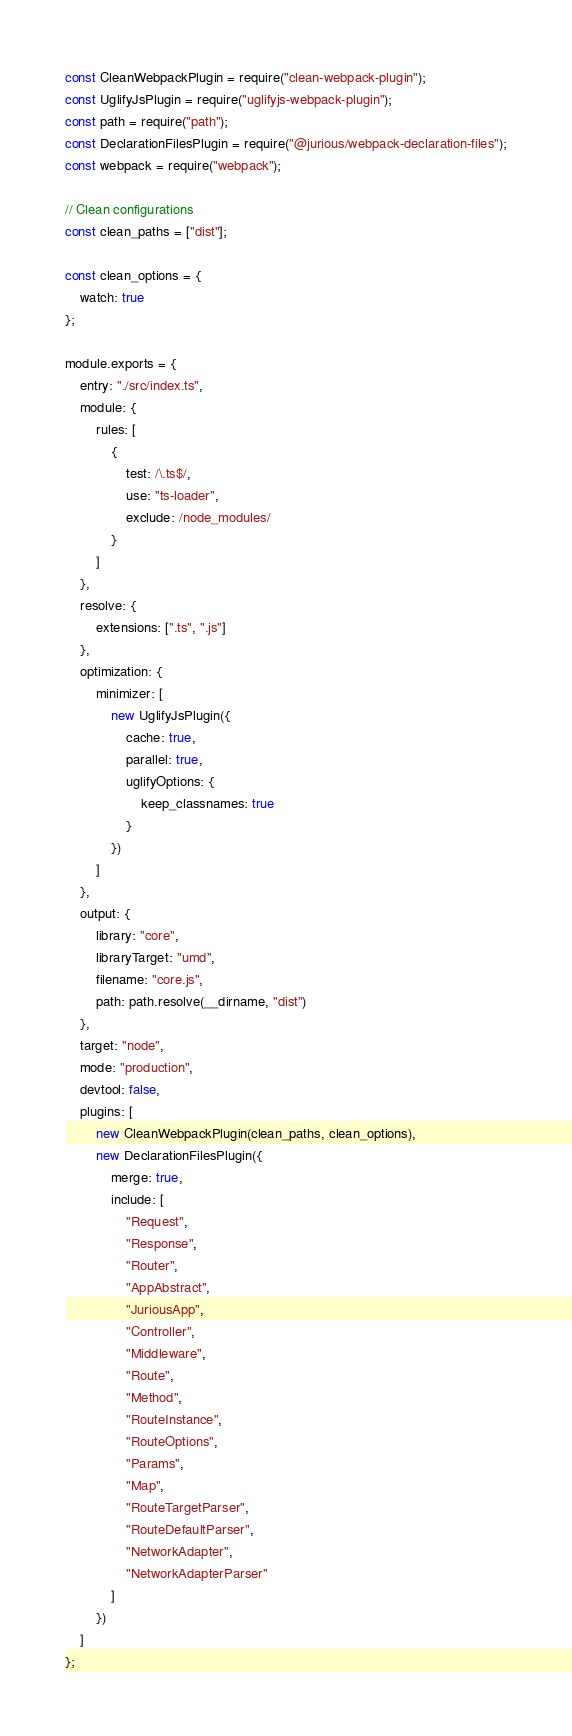<code> <loc_0><loc_0><loc_500><loc_500><_JavaScript_>const CleanWebpackPlugin = require("clean-webpack-plugin");
const UglifyJsPlugin = require("uglifyjs-webpack-plugin");
const path = require("path");
const DeclarationFilesPlugin = require("@jurious/webpack-declaration-files");
const webpack = require("webpack");

// Clean configurations
const clean_paths = ["dist"];

const clean_options = {
    watch: true
};

module.exports = {
    entry: "./src/index.ts",
    module: {
        rules: [
            {
                test: /\.ts$/,
                use: "ts-loader",
                exclude: /node_modules/
            }
        ]
    },
    resolve: {
        extensions: [".ts", ".js"]
    },
    optimization: {
        minimizer: [
            new UglifyJsPlugin({
                cache: true,
                parallel: true,
                uglifyOptions: {
                    keep_classnames: true
                }
            })
        ]
    },
    output: {
        library: "core",
        libraryTarget: "umd",
        filename: "core.js",
        path: path.resolve(__dirname, "dist")
    },
    target: "node",
    mode: "production",
    devtool: false,
    plugins: [
        new CleanWebpackPlugin(clean_paths, clean_options),
        new DeclarationFilesPlugin({
            merge: true,
            include: [
                "Request",
                "Response",
                "Router",
                "AppAbstract",
                "JuriousApp",
                "Controller",
                "Middleware",
                "Route",
                "Method",
                "RouteInstance",
                "RouteOptions",
                "Params",
                "Map",
                "RouteTargetParser",
                "RouteDefaultParser",
                "NetworkAdapter",
                "NetworkAdapterParser"
            ]
        })
    ]
};
</code> 